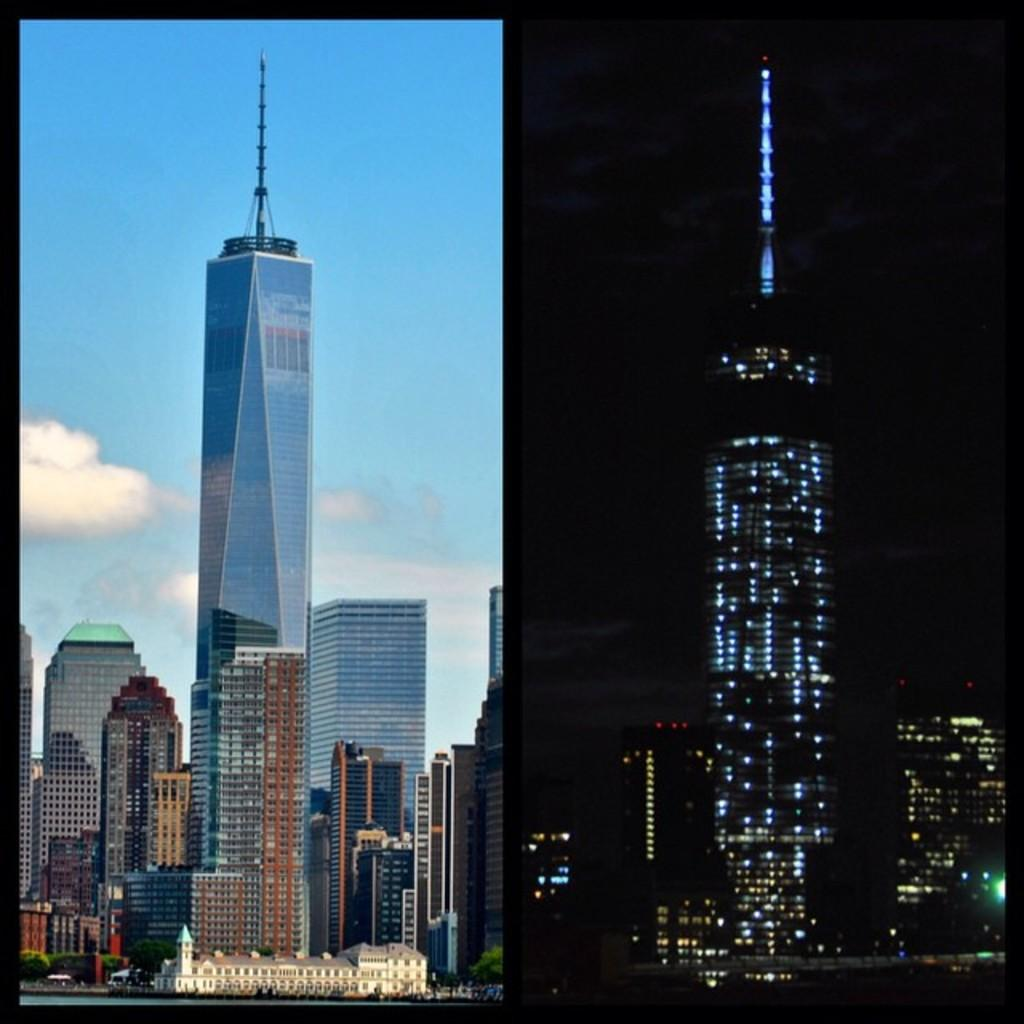What type of structures can be seen in the image? There are buildings in the image. What natural feature is present in the image? There is a lake in the image. What is visible in the sky in the image? The sky with clouds is visible in the image. Where are the buildings located in the image? The buildings are on the right side of the image. What else can be seen on the right side of the image? There are lights on the right side of the image. What type of rice is being cooked on the sidewalk in the image? There is no rice or sidewalk present in the image. What type of work is being done on the buildings in the image? The image does not show any work being done on the buildings; it only shows the buildings themselves. 